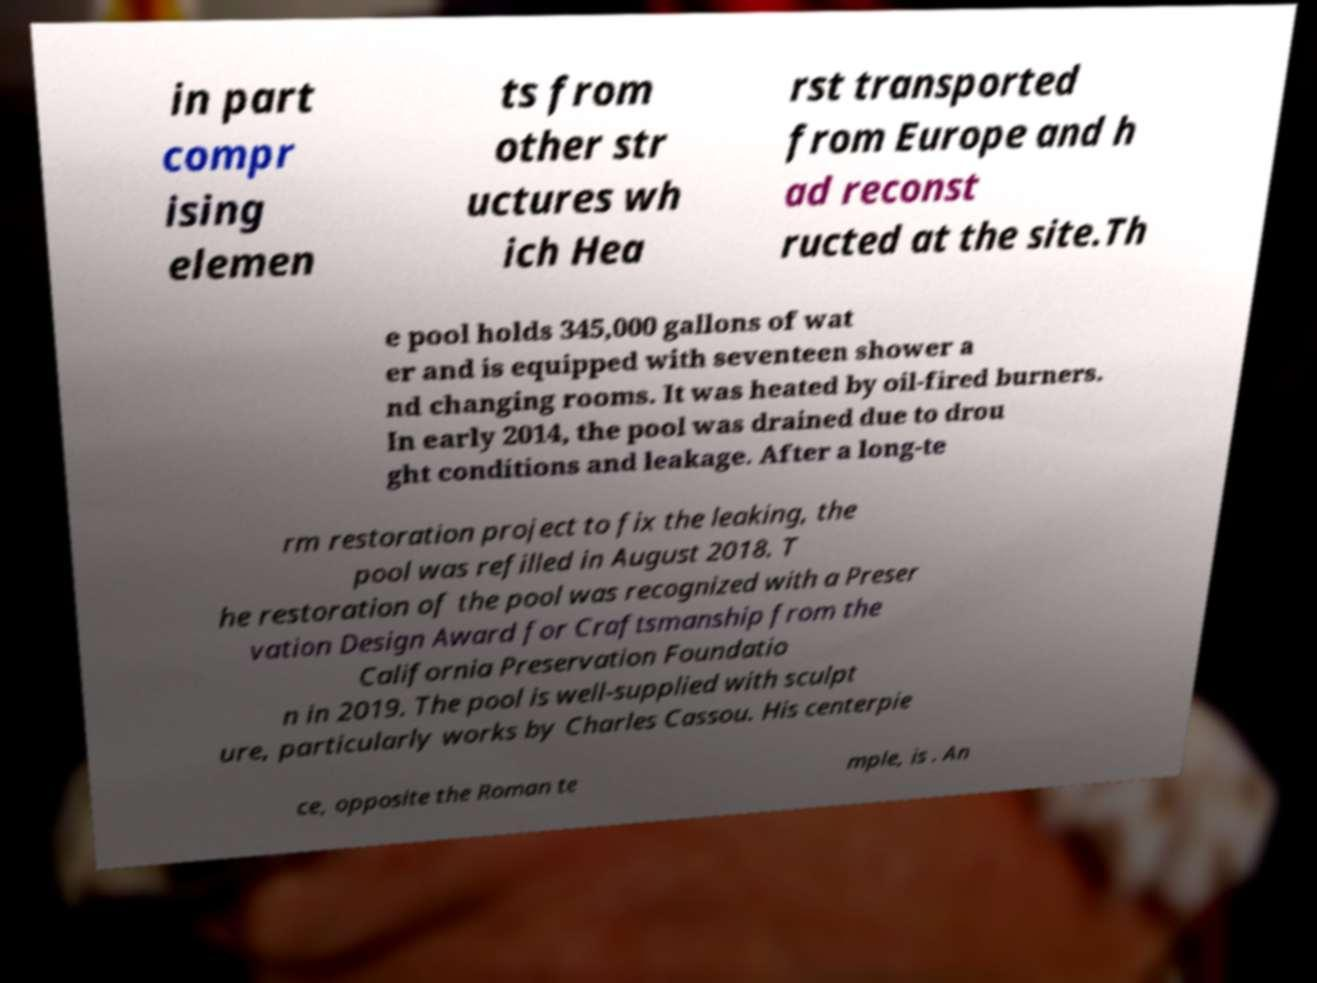Can you read and provide the text displayed in the image?This photo seems to have some interesting text. Can you extract and type it out for me? in part compr ising elemen ts from other str uctures wh ich Hea rst transported from Europe and h ad reconst ructed at the site.Th e pool holds 345,000 gallons of wat er and is equipped with seventeen shower a nd changing rooms. It was heated by oil-fired burners. In early 2014, the pool was drained due to drou ght conditions and leakage. After a long-te rm restoration project to fix the leaking, the pool was refilled in August 2018. T he restoration of the pool was recognized with a Preser vation Design Award for Craftsmanship from the California Preservation Foundatio n in 2019. The pool is well-supplied with sculpt ure, particularly works by Charles Cassou. His centerpie ce, opposite the Roman te mple, is . An 